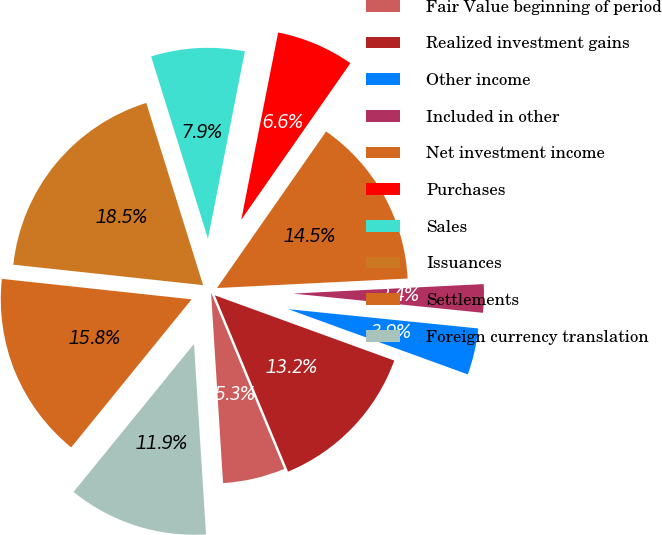<chart> <loc_0><loc_0><loc_500><loc_500><pie_chart><fcel>Fair Value beginning of period<fcel>Realized investment gains<fcel>Other income<fcel>Included in other<fcel>Net investment income<fcel>Purchases<fcel>Sales<fcel>Issuances<fcel>Settlements<fcel>Foreign currency translation<nl><fcel>5.26%<fcel>13.19%<fcel>3.94%<fcel>2.4%<fcel>14.52%<fcel>6.59%<fcel>7.91%<fcel>18.48%<fcel>15.84%<fcel>11.87%<nl></chart> 